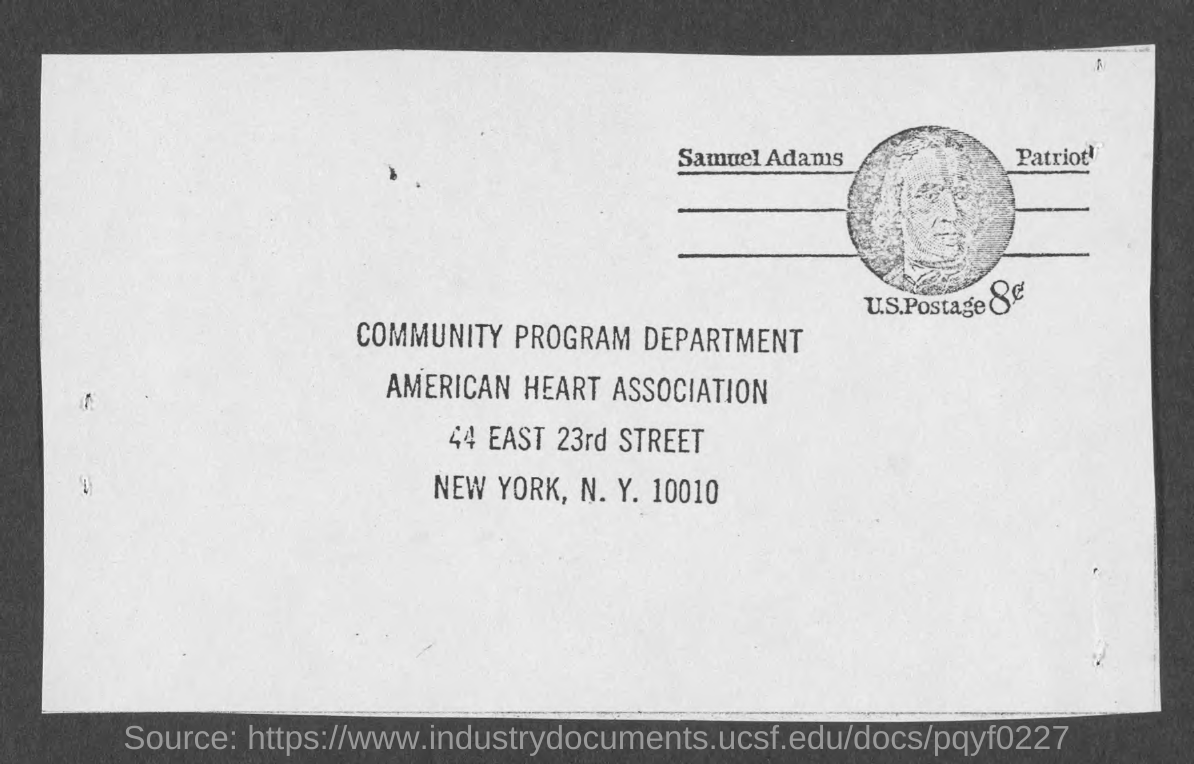Point out several critical features in this image. The city of New York is mentioned. The Community Program Department is mentioned. What zip code is mentioned? It is 10010. The American Heart Association is mentioned. 